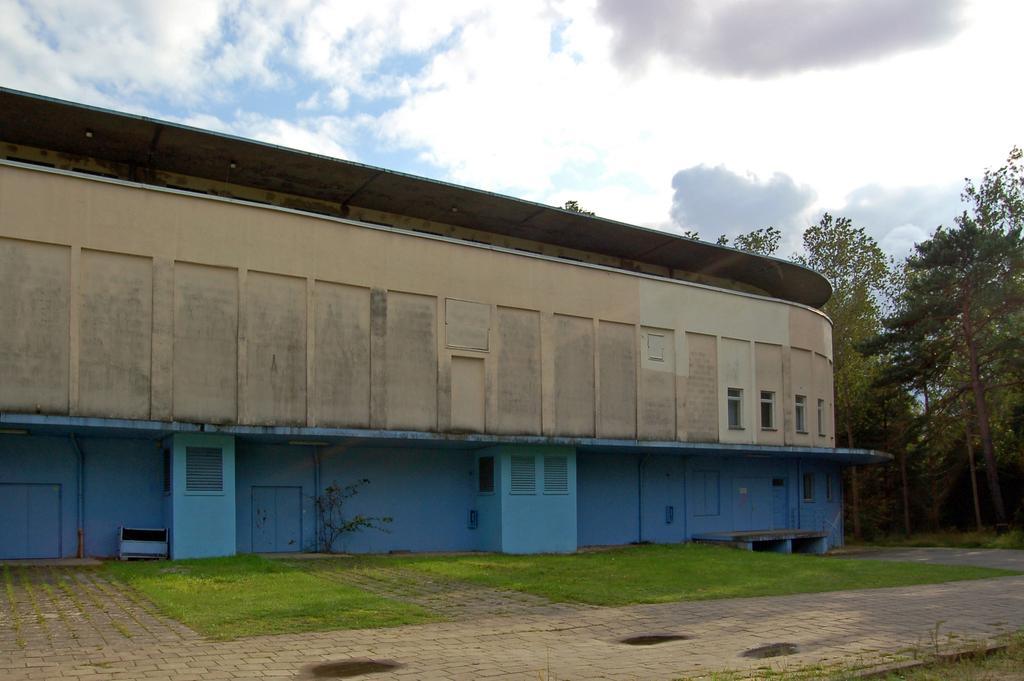In one or two sentences, can you explain what this image depicts? In this picture we can see the grass, path, fence, trees, building with windows and in the background we can see the sky with clouds. 